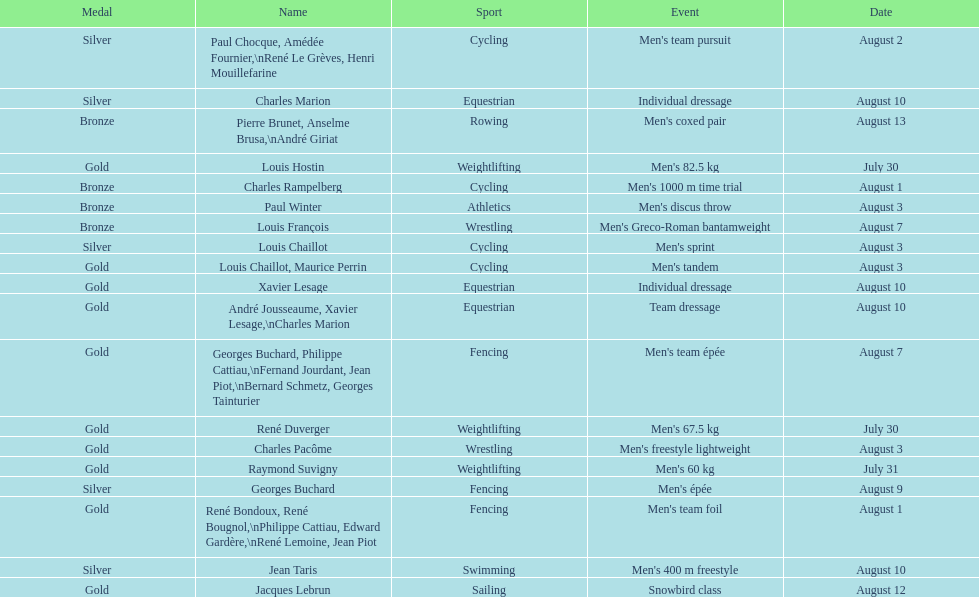What event is listed right before team dressage? Individual dressage. 